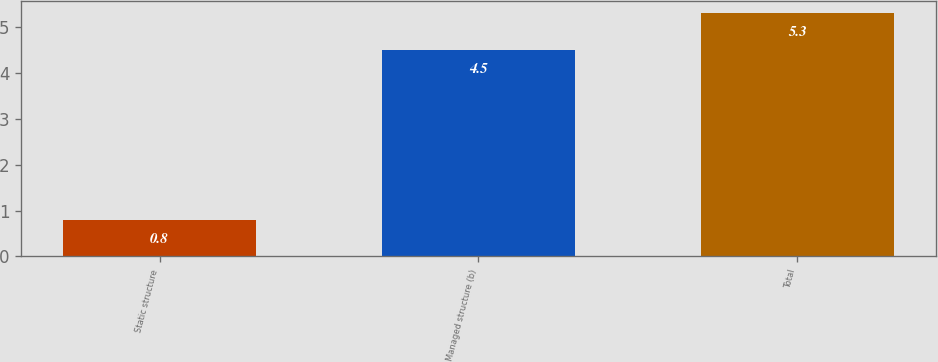Convert chart to OTSL. <chart><loc_0><loc_0><loc_500><loc_500><bar_chart><fcel>Static structure<fcel>Managed structure (b)<fcel>Total<nl><fcel>0.8<fcel>4.5<fcel>5.3<nl></chart> 